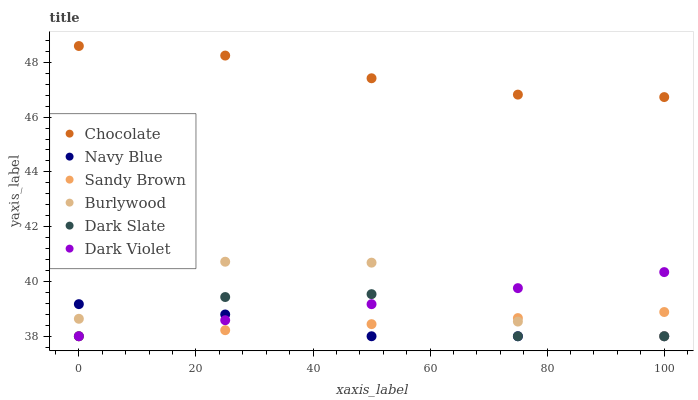Does Navy Blue have the minimum area under the curve?
Answer yes or no. Yes. Does Chocolate have the maximum area under the curve?
Answer yes or no. Yes. Does Dark Violet have the minimum area under the curve?
Answer yes or no. No. Does Dark Violet have the maximum area under the curve?
Answer yes or no. No. Is Sandy Brown the smoothest?
Answer yes or no. Yes. Is Burlywood the roughest?
Answer yes or no. Yes. Is Navy Blue the smoothest?
Answer yes or no. No. Is Navy Blue the roughest?
Answer yes or no. No. Does Burlywood have the lowest value?
Answer yes or no. Yes. Does Chocolate have the lowest value?
Answer yes or no. No. Does Chocolate have the highest value?
Answer yes or no. Yes. Does Navy Blue have the highest value?
Answer yes or no. No. Is Sandy Brown less than Chocolate?
Answer yes or no. Yes. Is Chocolate greater than Sandy Brown?
Answer yes or no. Yes. Does Navy Blue intersect Dark Slate?
Answer yes or no. Yes. Is Navy Blue less than Dark Slate?
Answer yes or no. No. Is Navy Blue greater than Dark Slate?
Answer yes or no. No. Does Sandy Brown intersect Chocolate?
Answer yes or no. No. 